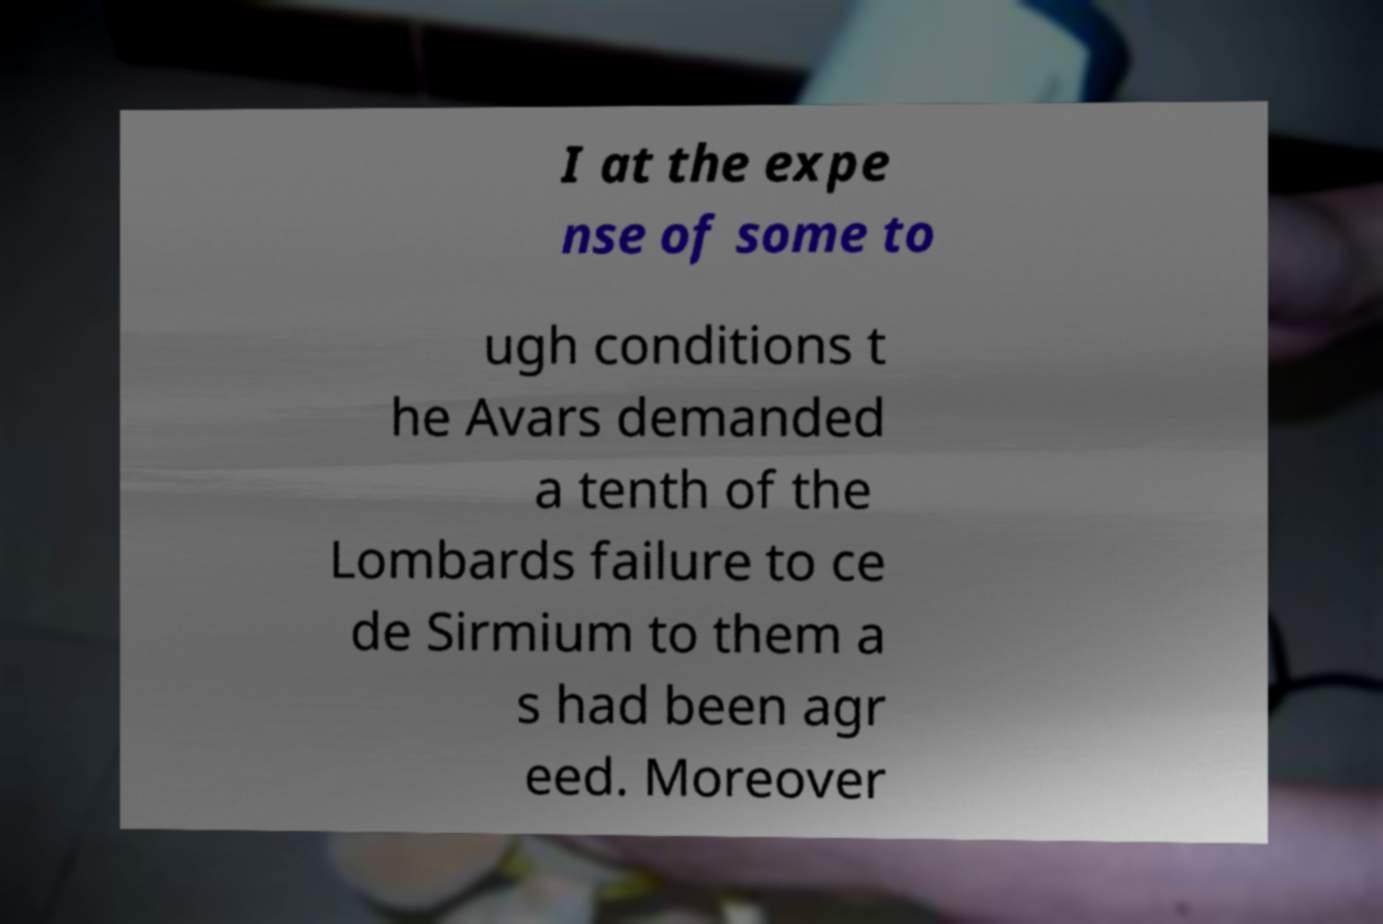I need the written content from this picture converted into text. Can you do that? I at the expe nse of some to ugh conditions t he Avars demanded a tenth of the Lombards failure to ce de Sirmium to them a s had been agr eed. Moreover 